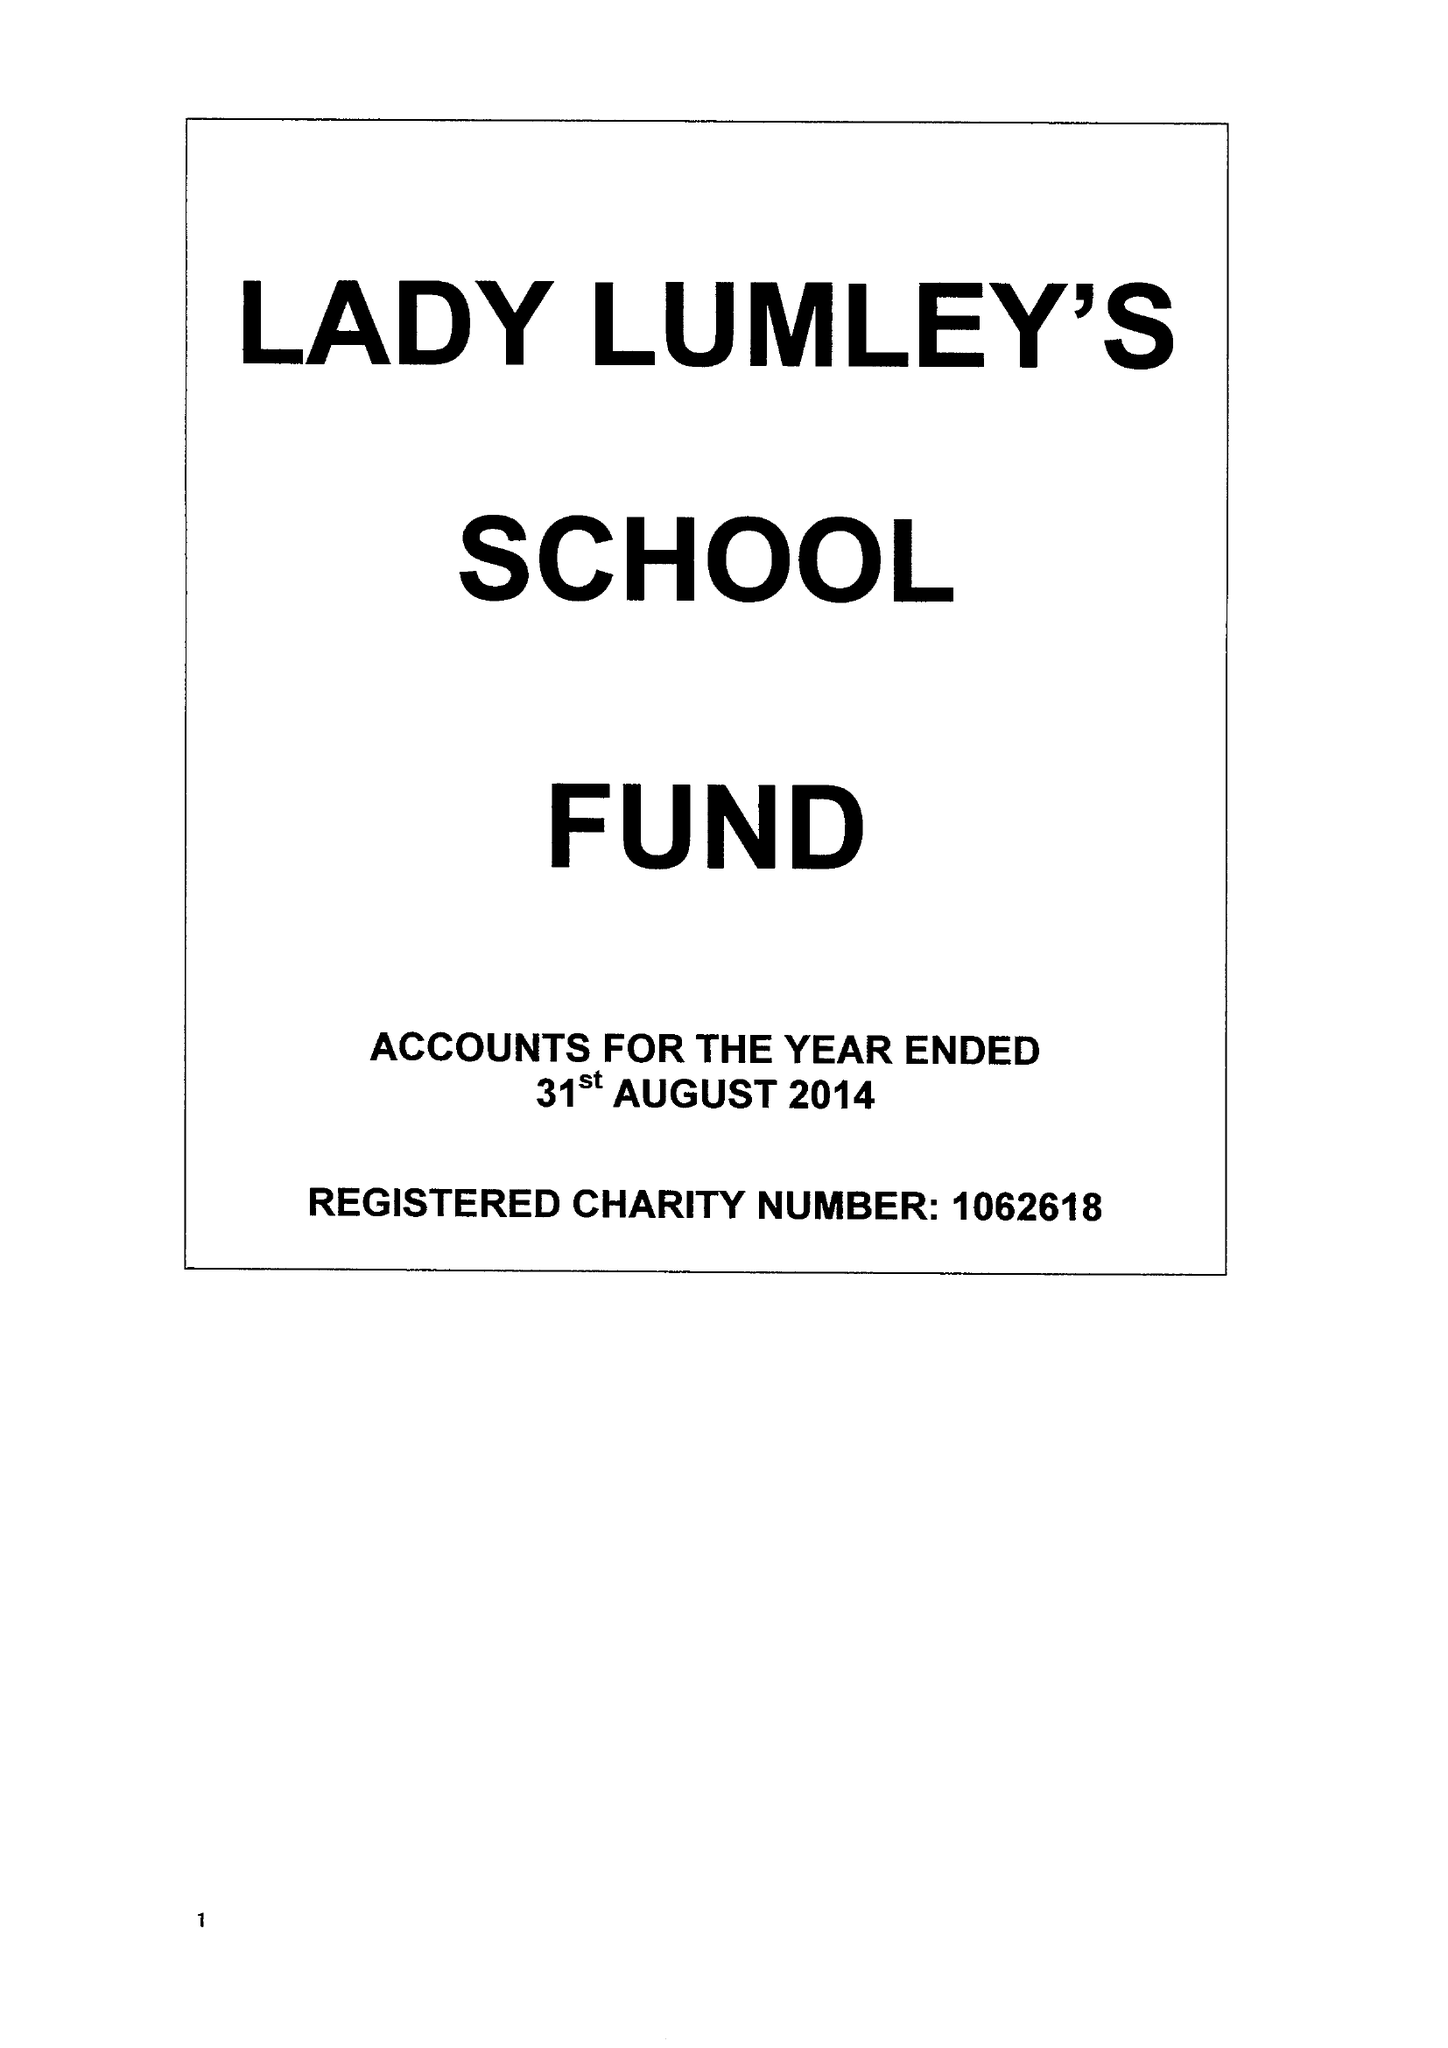What is the value for the spending_annually_in_british_pounds?
Answer the question using a single word or phrase. 140835.00 